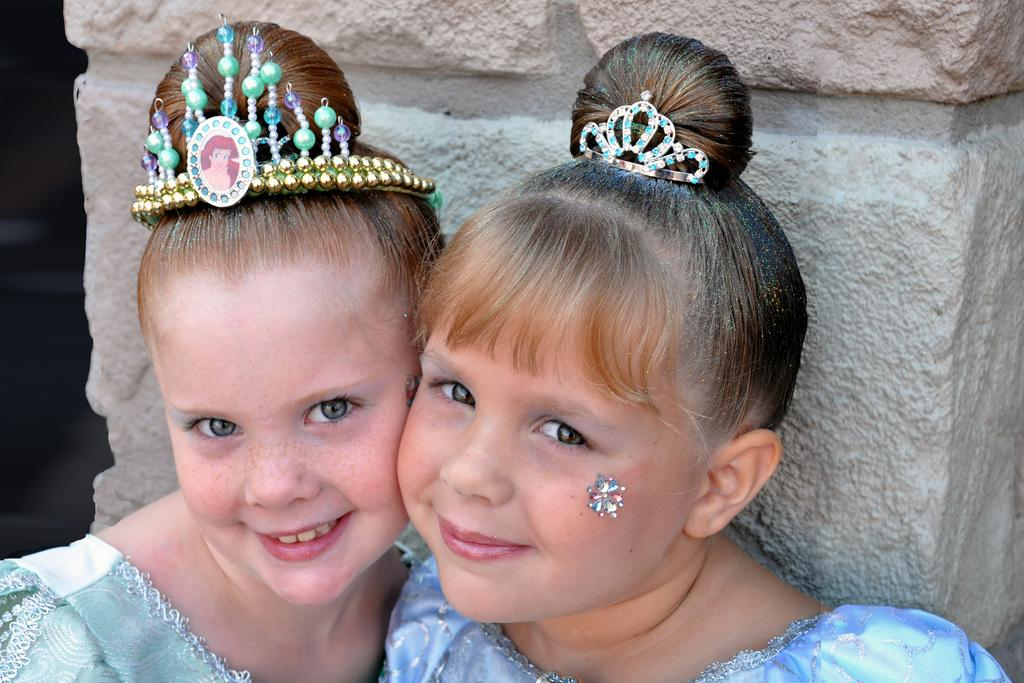How many people are in the image? There are two people in the image. What are the people doing in the image? Both people are smiling in the image. What are the people wearing in the image? The people are wearing blue dresses in the image. How do the people differ in their appearance? The people have different head wears in the image. What can be seen in the background of the image? There is a rock-pillar visible in the background of the image. What type of balls are being used by the people in the image? There are no balls present in the image. Can you tell me the size of the needle used by the people in the image? There is no needle present in the image. 